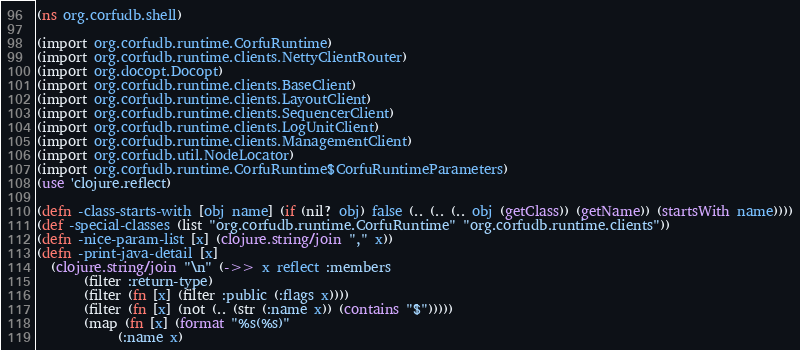<code> <loc_0><loc_0><loc_500><loc_500><_Clojure_>(ns org.corfudb.shell)

(import org.corfudb.runtime.CorfuRuntime)
(import org.corfudb.runtime.clients.NettyClientRouter)
(import org.docopt.Docopt)
(import org.corfudb.runtime.clients.BaseClient)
(import org.corfudb.runtime.clients.LayoutClient)
(import org.corfudb.runtime.clients.SequencerClient)
(import org.corfudb.runtime.clients.LogUnitClient)
(import org.corfudb.runtime.clients.ManagementClient)
(import org.corfudb.util.NodeLocator)
(import org.corfudb.runtime.CorfuRuntime$CorfuRuntimeParameters)
(use 'clojure.reflect)

(defn -class-starts-with [obj name] (if (nil? obj) false (.. (.. (.. obj (getClass)) (getName)) (startsWith name))))
(def -special-classes (list "org.corfudb.runtime.CorfuRuntime" "org.corfudb.runtime.clients"))
(defn -nice-param-list [x] (clojure.string/join "," x))
(defn -print-java-detail [x]
  (clojure.string/join "\n" (->> x reflect :members
       (filter :return-type)
       (filter (fn [x] (filter :public (:flags x))))
       (filter (fn [x] (not (.. (str (:name x)) (contains "$")))))
       (map (fn [x] (format "%s(%s)"
            (:name x)</code> 